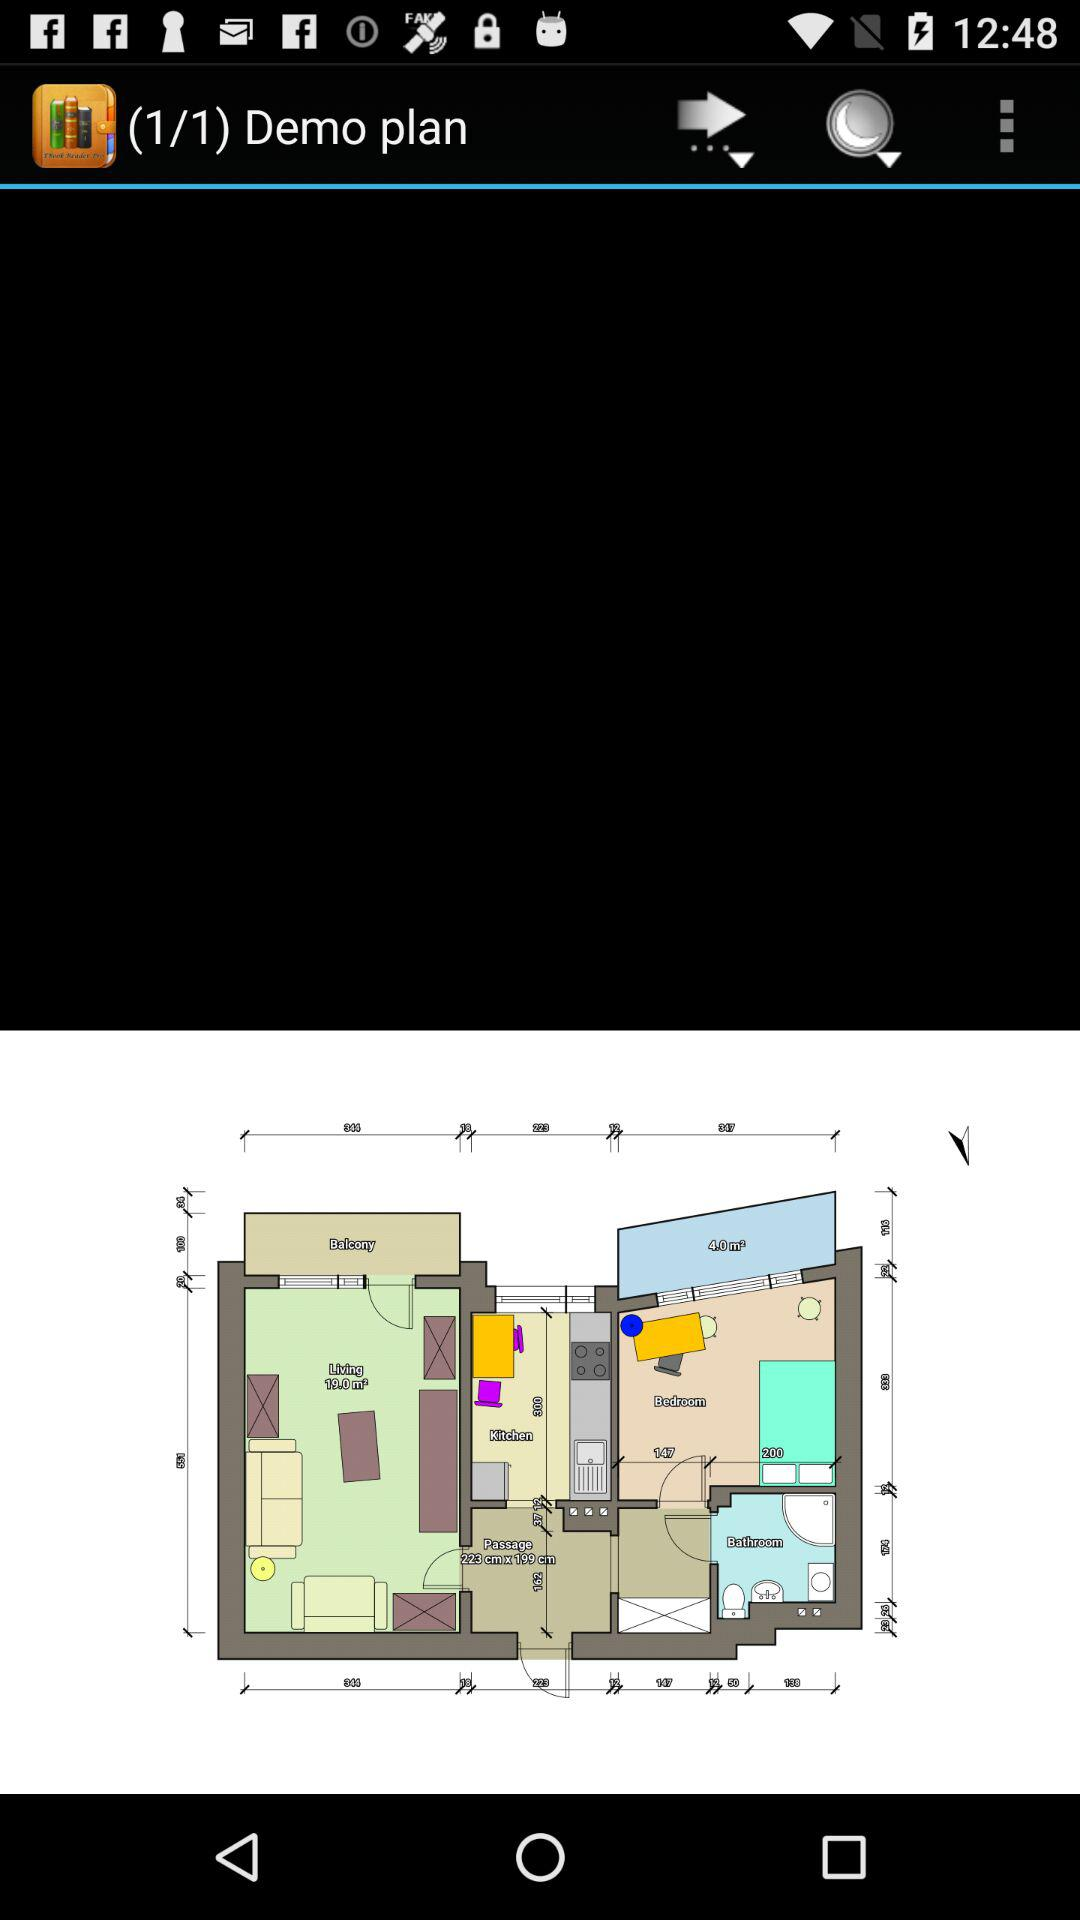How many demo plans in total are there? There is 1 demo plan. 